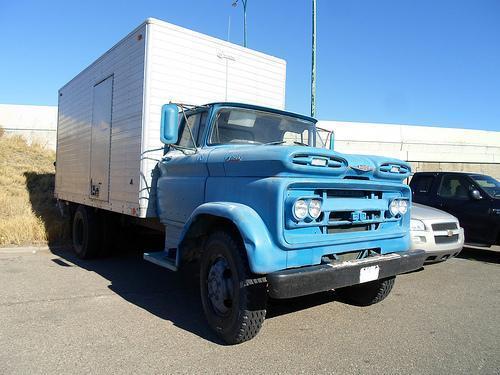How many cars are next to the truck?
Give a very brief answer. 2. How many red trucks are there?
Give a very brief answer. 0. 